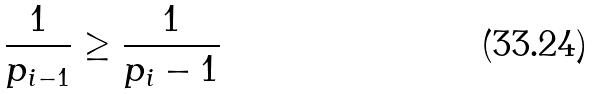Convert formula to latex. <formula><loc_0><loc_0><loc_500><loc_500>\frac { 1 } { p _ { i - 1 } } \geq \frac { 1 } { p _ { i } - 1 }</formula> 